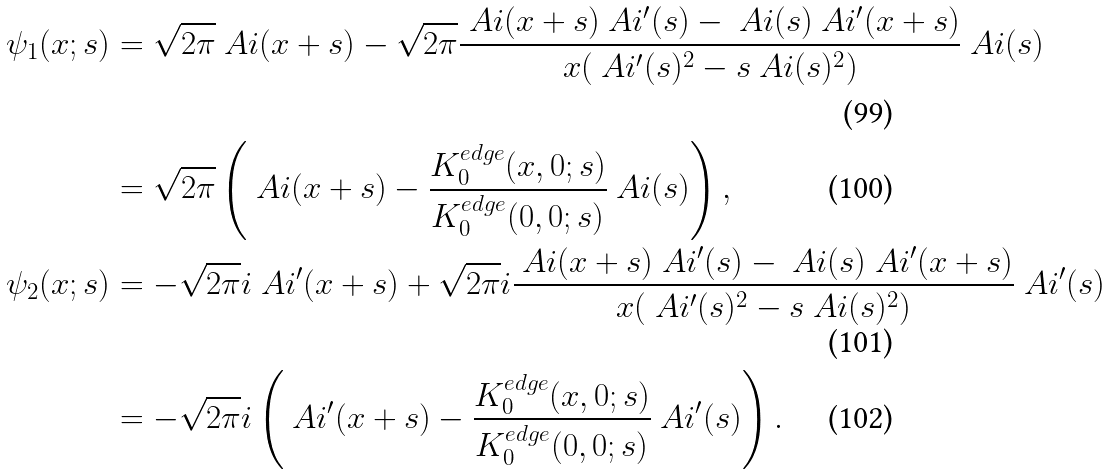Convert formula to latex. <formula><loc_0><loc_0><loc_500><loc_500>\psi _ { 1 } ( x ; s ) & = \sqrt { 2 \pi } \ A i ( x + s ) - \sqrt { 2 \pi } \frac { \ A i ( x + s ) \ A i ^ { \prime } ( s ) - \ A i ( s ) \ A i ^ { \prime } ( x + s ) } { x ( \ A i ^ { \prime } ( s ) ^ { 2 } - s \ A i ( s ) ^ { 2 } ) } \ A i ( s ) \\ & = \sqrt { 2 \pi } \left ( \ A i ( x + s ) - \frac { K _ { 0 } ^ { e d g e } ( x , 0 ; s ) } { K _ { 0 } ^ { e d g e } ( 0 , 0 ; s ) } \ A i ( s ) \right ) , \\ \psi _ { 2 } ( x ; s ) & = - \sqrt { 2 \pi } i \ A i ^ { \prime } ( x + s ) + \sqrt { 2 \pi } i \frac { \ A i ( x + s ) \ A i ^ { \prime } ( s ) - \ A i ( s ) \ A i ^ { \prime } ( x + s ) } { x ( \ A i ^ { \prime } ( s ) ^ { 2 } - s \ A i ( s ) ^ { 2 } ) } \ A i ^ { \prime } ( s ) \\ & = - \sqrt { 2 \pi } i \left ( \ A i ^ { \prime } ( x + s ) - \frac { K _ { 0 } ^ { e d g e } ( x , 0 ; s ) } { K _ { 0 } ^ { e d g e } ( 0 , 0 ; s ) } \ A i ^ { \prime } ( s ) \right ) .</formula> 